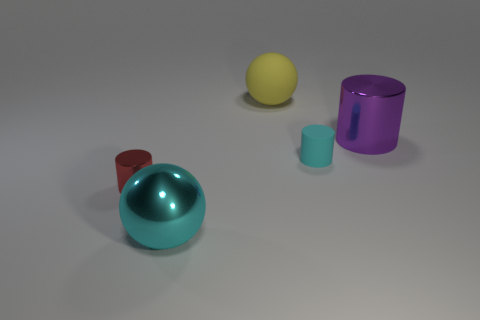What is the material of the tiny cylinder to the right of the matte sphere?
Ensure brevity in your answer.  Rubber. Are there the same number of large purple things that are to the left of the large cylinder and large yellow things in front of the tiny cyan cylinder?
Your answer should be compact. Yes. There is another metallic object that is the same shape as the purple metallic thing; what color is it?
Give a very brief answer. Red. Are there any other things of the same color as the large matte object?
Your response must be concise. No. How many rubber objects are either cyan spheres or yellow objects?
Give a very brief answer. 1. Does the rubber cylinder have the same color as the big shiny ball?
Provide a short and direct response. Yes. Is the number of metal cylinders that are on the left side of the cyan rubber cylinder greater than the number of cylinders?
Your answer should be compact. No. How many other things are there of the same material as the big yellow thing?
Provide a short and direct response. 1. How many large objects are cyan metallic objects or things?
Provide a short and direct response. 3. Is the material of the big yellow object the same as the cyan cylinder?
Provide a succinct answer. Yes. 